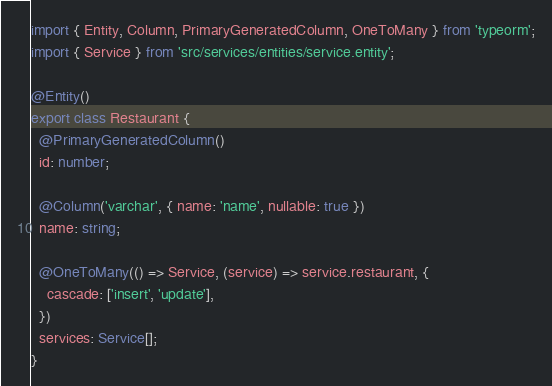<code> <loc_0><loc_0><loc_500><loc_500><_TypeScript_>import { Entity, Column, PrimaryGeneratedColumn, OneToMany } from 'typeorm';
import { Service } from 'src/services/entities/service.entity';

@Entity()
export class Restaurant {
  @PrimaryGeneratedColumn()
  id: number;

  @Column('varchar', { name: 'name', nullable: true })
  name: string;

  @OneToMany(() => Service, (service) => service.restaurant, {
    cascade: ['insert', 'update'],
  })
  services: Service[];
}
</code> 